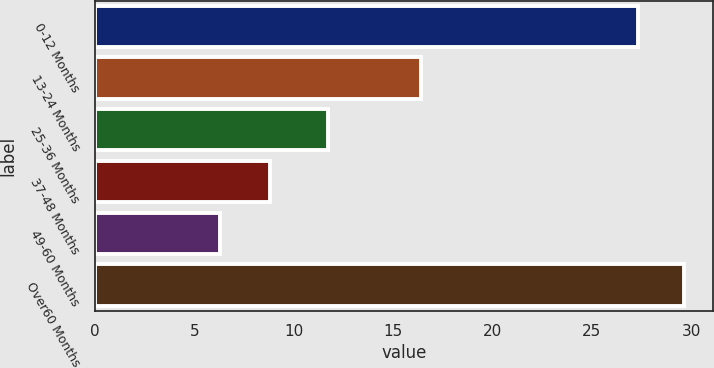Convert chart. <chart><loc_0><loc_0><loc_500><loc_500><bar_chart><fcel>0-12 Months<fcel>13-24 Months<fcel>25-36 Months<fcel>37-48 Months<fcel>49-60 Months<fcel>Over60 Months<nl><fcel>27.3<fcel>16.4<fcel>11.7<fcel>8.8<fcel>6.3<fcel>29.62<nl></chart> 